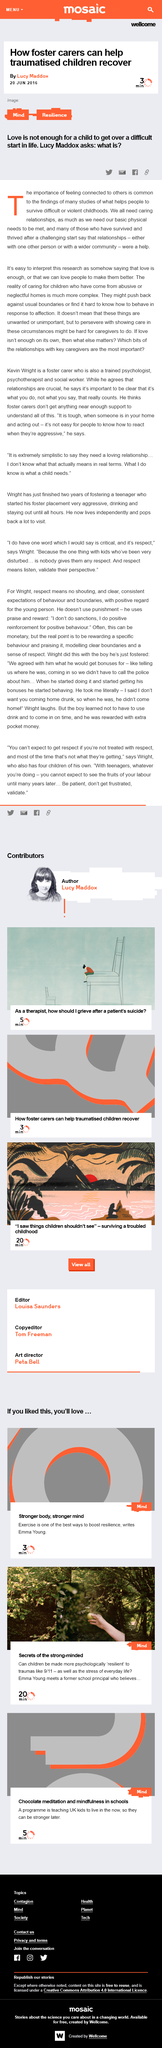Outline some significant characteristics in this image. The article was written by Lucy Maddox. There are five different ways to share this information. The information is intended for foster carers. 